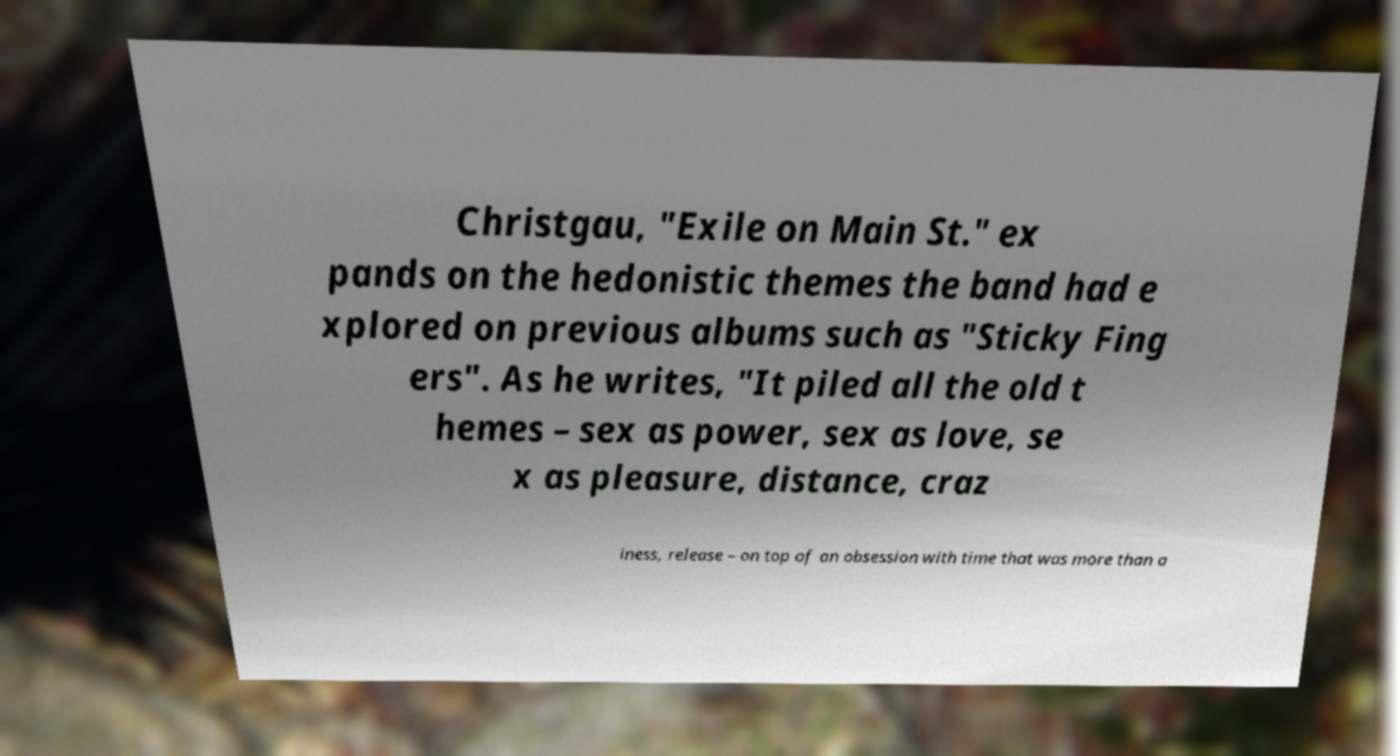I need the written content from this picture converted into text. Can you do that? Christgau, "Exile on Main St." ex pands on the hedonistic themes the band had e xplored on previous albums such as "Sticky Fing ers". As he writes, "It piled all the old t hemes – sex as power, sex as love, se x as pleasure, distance, craz iness, release – on top of an obsession with time that was more than a 